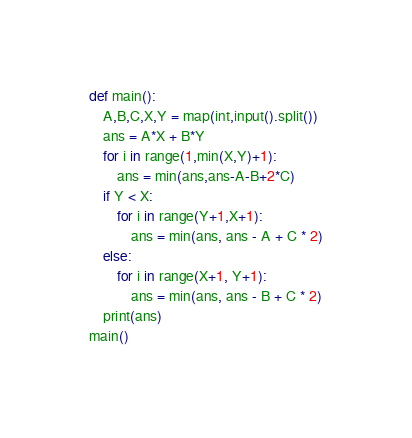<code> <loc_0><loc_0><loc_500><loc_500><_Python_>def main():
	A,B,C,X,Y = map(int,input().split())
	ans = A*X + B*Y
	for i in range(1,min(X,Y)+1):
		ans = min(ans,ans-A-B+2*C)
	if Y < X:
		for i in range(Y+1,X+1):
			ans = min(ans, ans - A + C * 2)
	else:
		for i in range(X+1, Y+1):
			ans = min(ans, ans - B + C * 2)
	print(ans)
main()</code> 